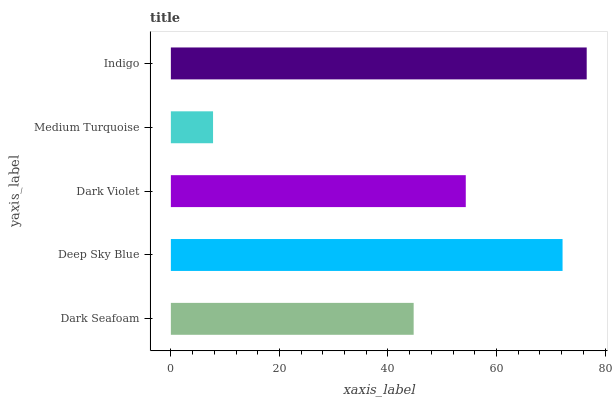Is Medium Turquoise the minimum?
Answer yes or no. Yes. Is Indigo the maximum?
Answer yes or no. Yes. Is Deep Sky Blue the minimum?
Answer yes or no. No. Is Deep Sky Blue the maximum?
Answer yes or no. No. Is Deep Sky Blue greater than Dark Seafoam?
Answer yes or no. Yes. Is Dark Seafoam less than Deep Sky Blue?
Answer yes or no. Yes. Is Dark Seafoam greater than Deep Sky Blue?
Answer yes or no. No. Is Deep Sky Blue less than Dark Seafoam?
Answer yes or no. No. Is Dark Violet the high median?
Answer yes or no. Yes. Is Dark Violet the low median?
Answer yes or no. Yes. Is Deep Sky Blue the high median?
Answer yes or no. No. Is Dark Seafoam the low median?
Answer yes or no. No. 